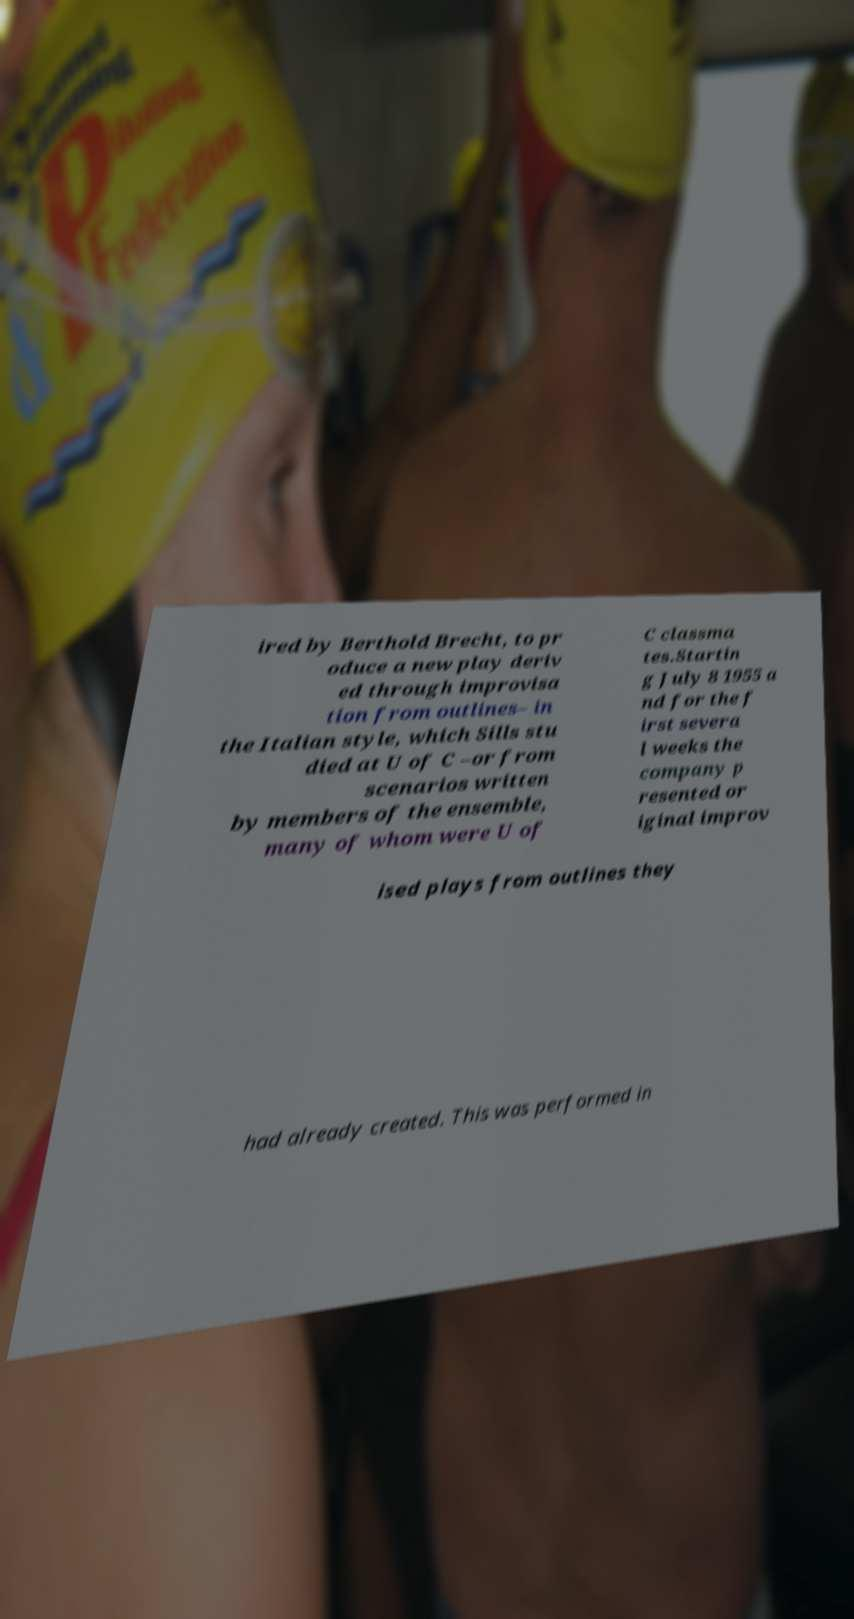Please read and relay the text visible in this image. What does it say? ired by Berthold Brecht, to pr oduce a new play deriv ed through improvisa tion from outlines– in the Italian style, which Sills stu died at U of C –or from scenarios written by members of the ensemble, many of whom were U of C classma tes.Startin g July 8 1955 a nd for the f irst severa l weeks the company p resented or iginal improv ised plays from outlines they had already created. This was performed in 